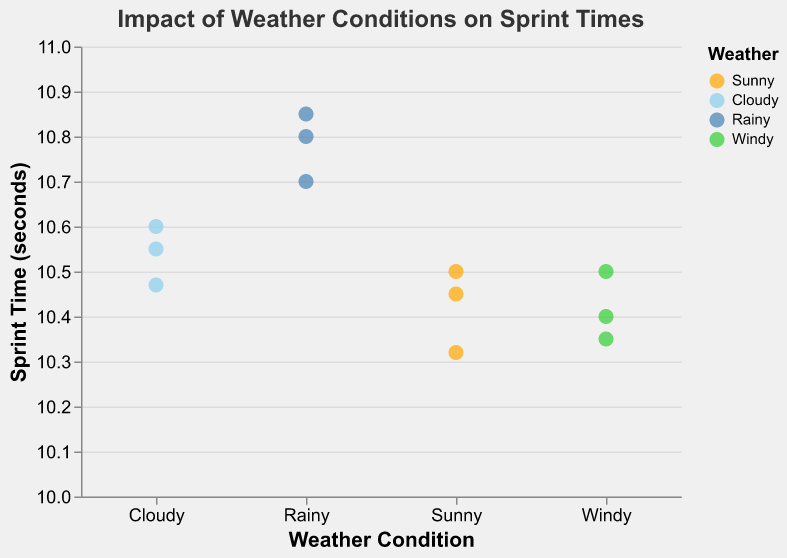How many data points are there for each weather condition? Count the number of sprint times recorded for each weather condition: Sunny (3), Cloudy (3), Rainy (3), Windy (3)
Answer: 3 What is the title of the scatter plot? Look at the text at the top of the scatter plot.
Answer: Impact of Weather Conditions on Sprint Times Which athlete has the fastest sprint time and under what weather condition? Identify the smallest sprint time value and the corresponding athlete and weather condition.
Answer: John Doe, Sunny What is the range of sprint times recorded under Cloudy conditions? Identify the minimum and maximum sprint times for Cloudy conditions and calculate the difference. Times: 10.47, 10.55, 10.60. Range = 10.60 - 10.47 = 0.13 seconds.
Answer: 0.13 seconds How do the median sprint times compare across different weather conditions? Calculate the median sprint time for each weather condition. Sunny: 10.45 (10.32, 10.45, 10.50); Cloudy: 10.55 (10.47, 10.55, 10.60); Rainy: 10.80 (10.70, 10.80, 10.85); Windy: 10.40 (10.35, 10.40, 10.50). Compare these values.
Answer: Sunny < Cloudy < Windy < Rainy Which weather condition has the slowest average sprint time? Calculate the average sprint time for each weather condition and compare them. Sunny: (10.32 + 10.45 + 10.50) / 3 = 10.42; Cloudy: (10.55 + 10.47 + 10.60) / 3 = 10.54; Rainy: (10.80 + 10.70 + 10.85) / 3 = 10.78; Windy: (10.40 + 10.35 + 10.50) / 3 = 10.42. Rainy has the highest average.
Answer: Rainy Based on the scatter plot, how does weather condition affect sprint times? Observe the data points' distribution for each weather condition and note any patterns or trends. Generally, sprint times are faster in Sunny and Windy conditions compared to Cloudy and Rainy conditions.
Answer: Sunny and Windy conditions have faster times, Rainy conditions have slower times What color represents the Rainy weather condition in the scatter plot? Identify the color used for the Rainy weather condition in the legend of the scatter plot.
Answer: Blue Which weather condition shows the most variability in sprint times? Determine the range (difference between maximum and minimum sprint times) for each weather condition. Sunny: 0.18; Cloudy: 0.13; Rainy: 0.15; Windy: 0.15. The condition with the largest range has the most variability.
Answer: Sunny 